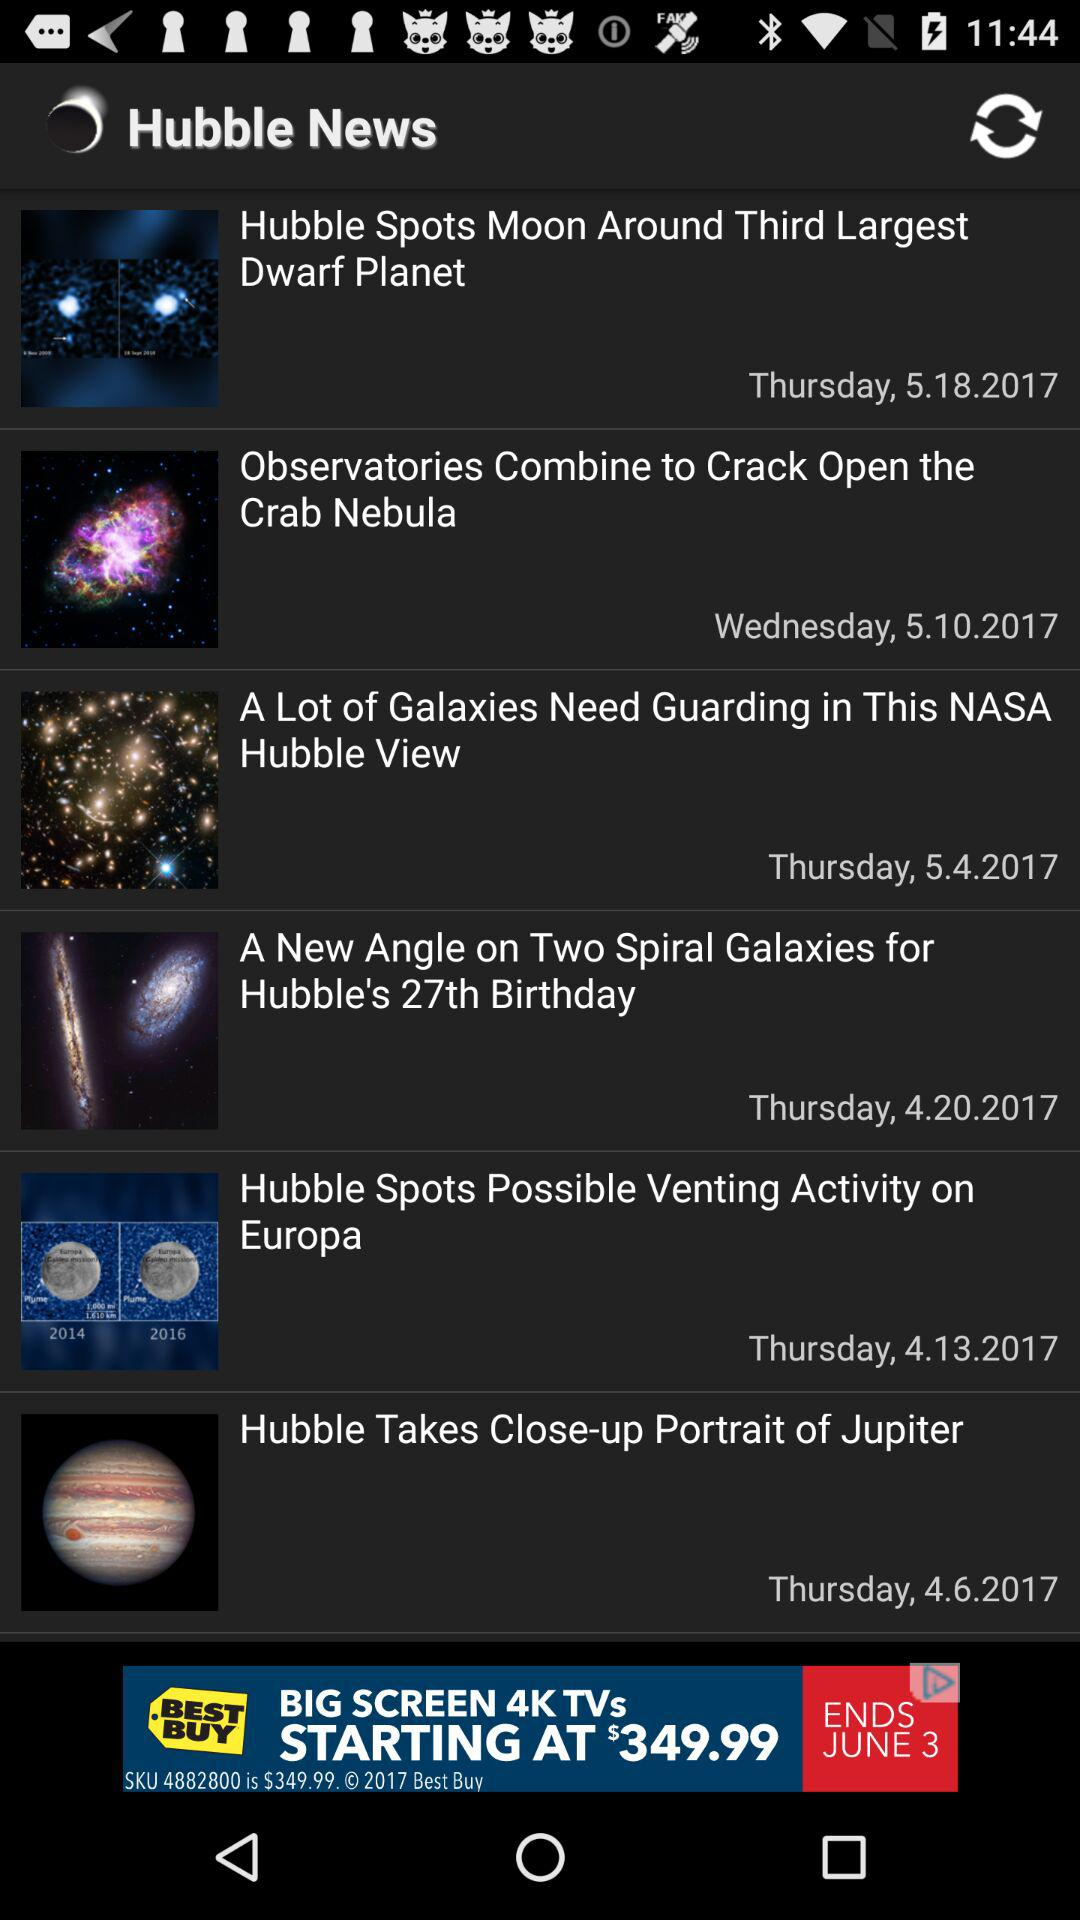Which news was posted on Wednesday? The news that was posted on Wednesday is "Observatories Combine to Crack Open the Crab Nebula". 